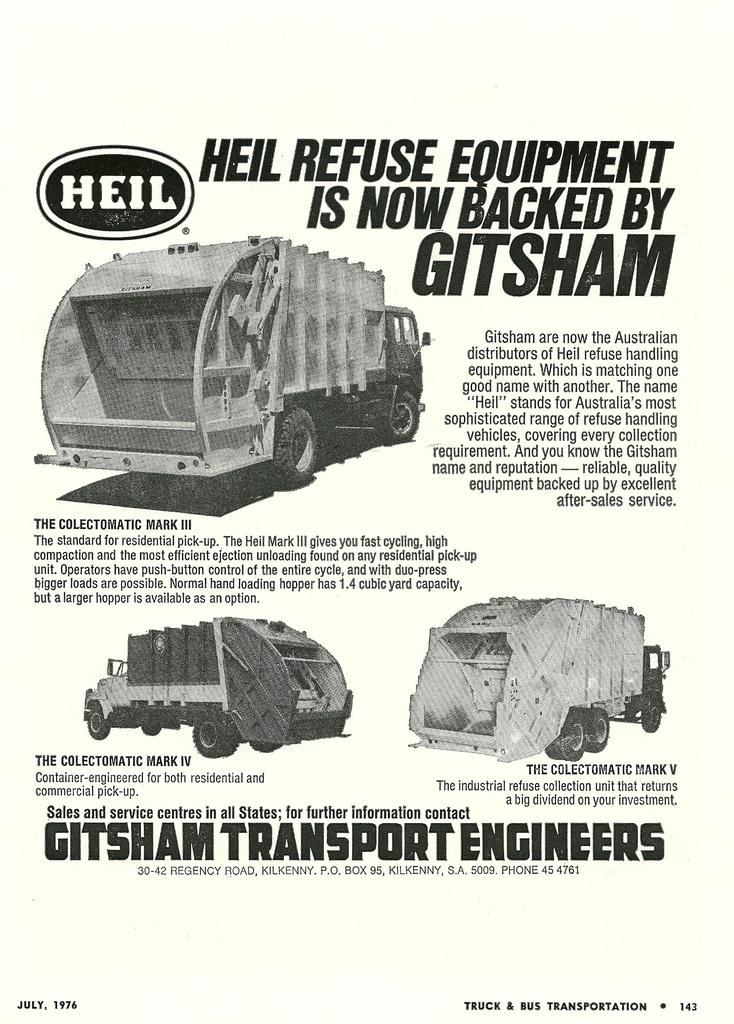What is featured in the image? There is a poster in the image. What can be found on the poster? There is text on the poster and images of vehicles. What type of corn is being displayed by the maid in the image? There is no corn or maid present in the image; it only features a poster with text and images of vehicles. 